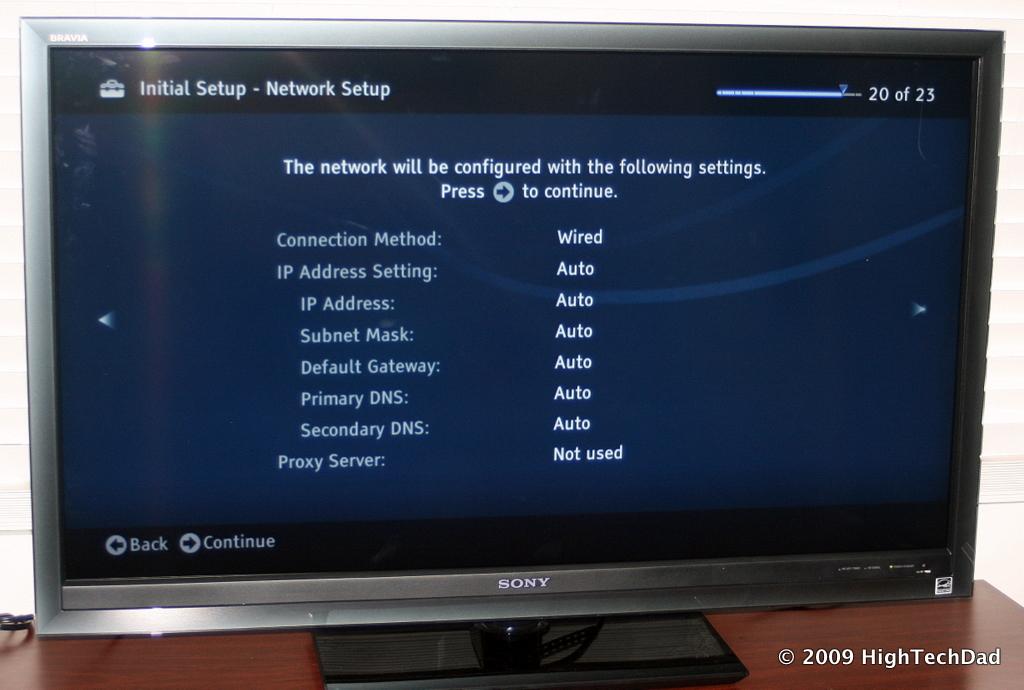What step are we on ?
Keep it short and to the point. 20. What brand of tv is this?
Offer a terse response. Sony. 